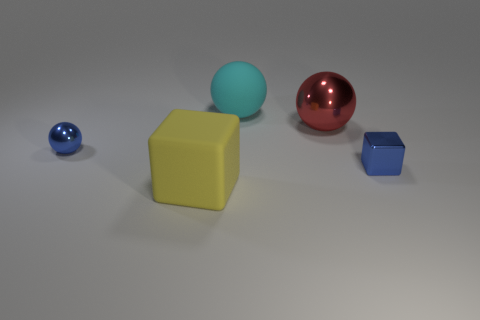Add 2 cubes. How many objects exist? 7 Subtract all blocks. How many objects are left? 3 Add 3 blue metal spheres. How many blue metal spheres are left? 4 Add 1 tiny blue cubes. How many tiny blue cubes exist? 2 Subtract 0 brown cylinders. How many objects are left? 5 Subtract all tiny blue blocks. Subtract all large matte things. How many objects are left? 2 